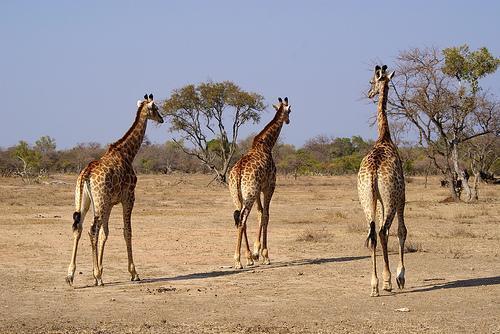How many giraffes are in the picture?
Give a very brief answer. 3. How many giraffe feet are in the picture?
Give a very brief answer. 12. How many giraffe are shown?
Give a very brief answer. 3. 